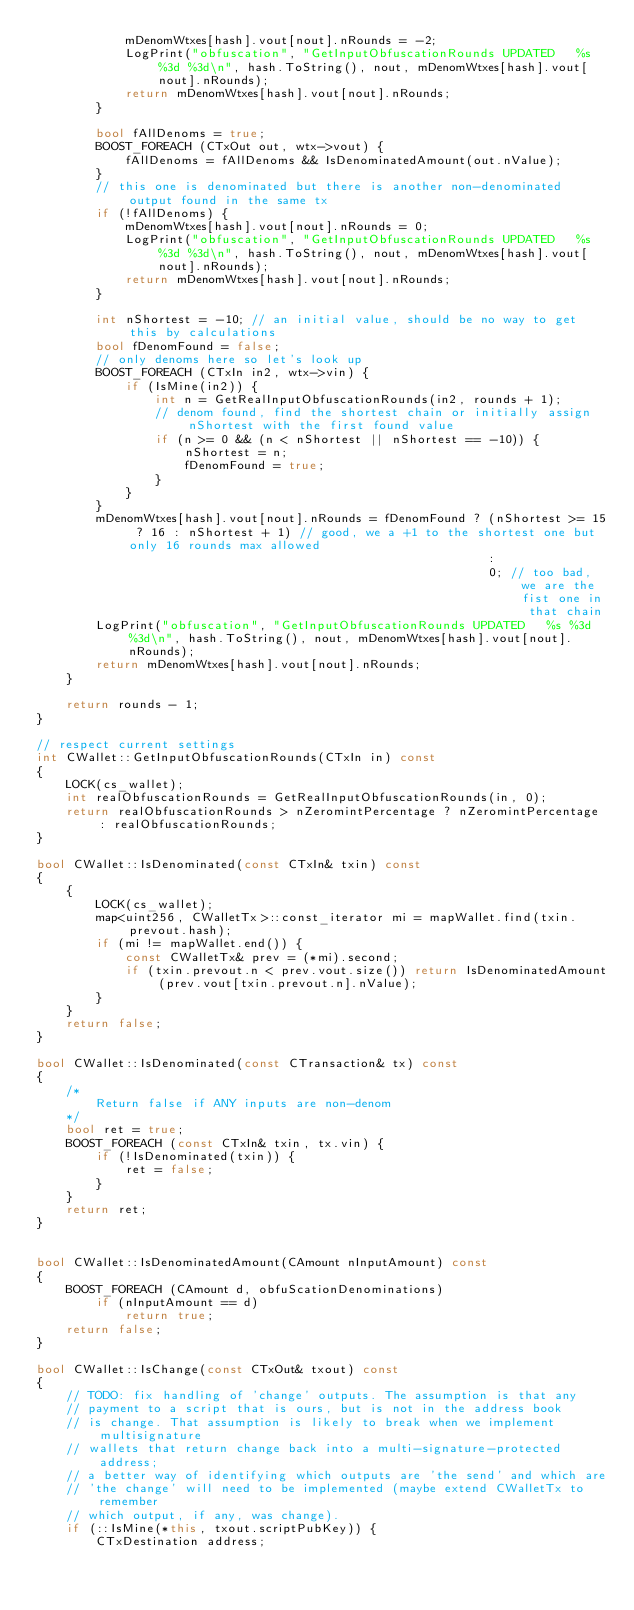Convert code to text. <code><loc_0><loc_0><loc_500><loc_500><_C++_>            mDenomWtxes[hash].vout[nout].nRounds = -2;
            LogPrint("obfuscation", "GetInputObfuscationRounds UPDATED   %s %3d %3d\n", hash.ToString(), nout, mDenomWtxes[hash].vout[nout].nRounds);
            return mDenomWtxes[hash].vout[nout].nRounds;
        }

        bool fAllDenoms = true;
        BOOST_FOREACH (CTxOut out, wtx->vout) {
            fAllDenoms = fAllDenoms && IsDenominatedAmount(out.nValue);
        }
        // this one is denominated but there is another non-denominated output found in the same tx
        if (!fAllDenoms) {
            mDenomWtxes[hash].vout[nout].nRounds = 0;
            LogPrint("obfuscation", "GetInputObfuscationRounds UPDATED   %s %3d %3d\n", hash.ToString(), nout, mDenomWtxes[hash].vout[nout].nRounds);
            return mDenomWtxes[hash].vout[nout].nRounds;
        }

        int nShortest = -10; // an initial value, should be no way to get this by calculations
        bool fDenomFound = false;
        // only denoms here so let's look up
        BOOST_FOREACH (CTxIn in2, wtx->vin) {
            if (IsMine(in2)) {
                int n = GetRealInputObfuscationRounds(in2, rounds + 1);
                // denom found, find the shortest chain or initially assign nShortest with the first found value
                if (n >= 0 && (n < nShortest || nShortest == -10)) {
                    nShortest = n;
                    fDenomFound = true;
                }
            }
        }
        mDenomWtxes[hash].vout[nout].nRounds = fDenomFound ? (nShortest >= 15 ? 16 : nShortest + 1) // good, we a +1 to the shortest one but only 16 rounds max allowed
                                                             :
                                                             0; // too bad, we are the fist one in that chain
        LogPrint("obfuscation", "GetInputObfuscationRounds UPDATED   %s %3d %3d\n", hash.ToString(), nout, mDenomWtxes[hash].vout[nout].nRounds);
        return mDenomWtxes[hash].vout[nout].nRounds;
    }

    return rounds - 1;
}

// respect current settings
int CWallet::GetInputObfuscationRounds(CTxIn in) const
{
    LOCK(cs_wallet);
    int realObfuscationRounds = GetRealInputObfuscationRounds(in, 0);
    return realObfuscationRounds > nZeromintPercentage ? nZeromintPercentage : realObfuscationRounds;
}

bool CWallet::IsDenominated(const CTxIn& txin) const
{
    {
        LOCK(cs_wallet);
        map<uint256, CWalletTx>::const_iterator mi = mapWallet.find(txin.prevout.hash);
        if (mi != mapWallet.end()) {
            const CWalletTx& prev = (*mi).second;
            if (txin.prevout.n < prev.vout.size()) return IsDenominatedAmount(prev.vout[txin.prevout.n].nValue);
        }
    }
    return false;
}

bool CWallet::IsDenominated(const CTransaction& tx) const
{
    /*
        Return false if ANY inputs are non-denom
    */
    bool ret = true;
    BOOST_FOREACH (const CTxIn& txin, tx.vin) {
        if (!IsDenominated(txin)) {
            ret = false;
        }
    }
    return ret;
}


bool CWallet::IsDenominatedAmount(CAmount nInputAmount) const
{
    BOOST_FOREACH (CAmount d, obfuScationDenominations)
        if (nInputAmount == d)
            return true;
    return false;
}

bool CWallet::IsChange(const CTxOut& txout) const
{
    // TODO: fix handling of 'change' outputs. The assumption is that any
    // payment to a script that is ours, but is not in the address book
    // is change. That assumption is likely to break when we implement multisignature
    // wallets that return change back into a multi-signature-protected address;
    // a better way of identifying which outputs are 'the send' and which are
    // 'the change' will need to be implemented (maybe extend CWalletTx to remember
    // which output, if any, was change).
    if (::IsMine(*this, txout.scriptPubKey)) {
        CTxDestination address;</code> 